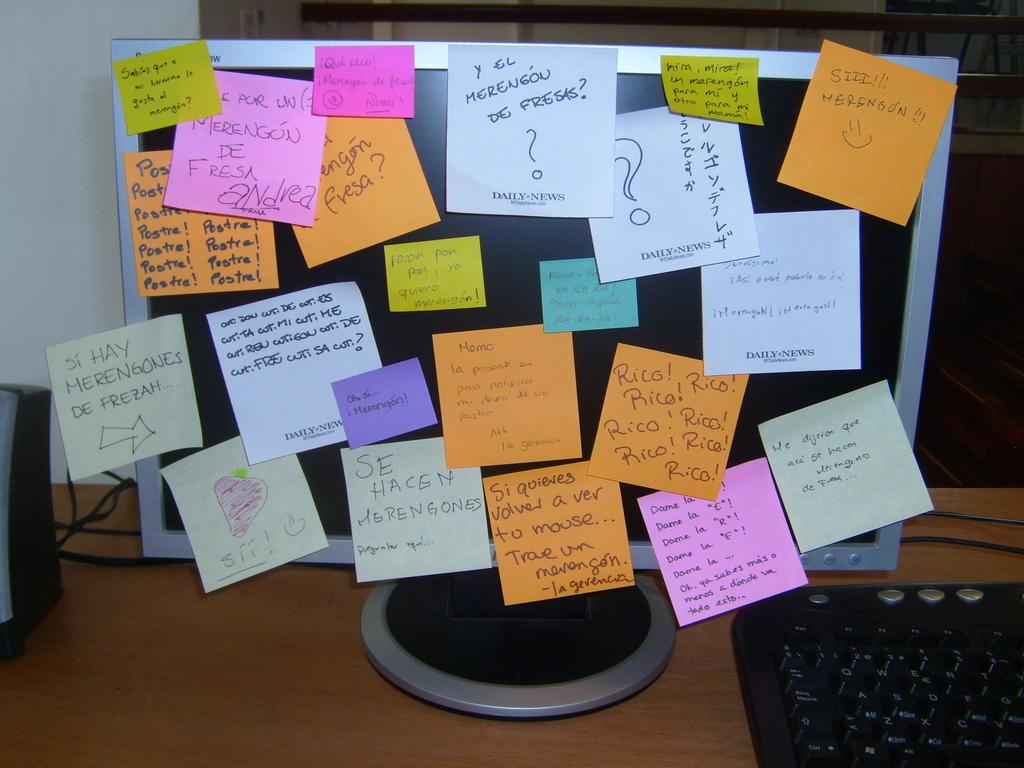What news organization is on the bottom of the notes?
Give a very brief answer. Daily news. 